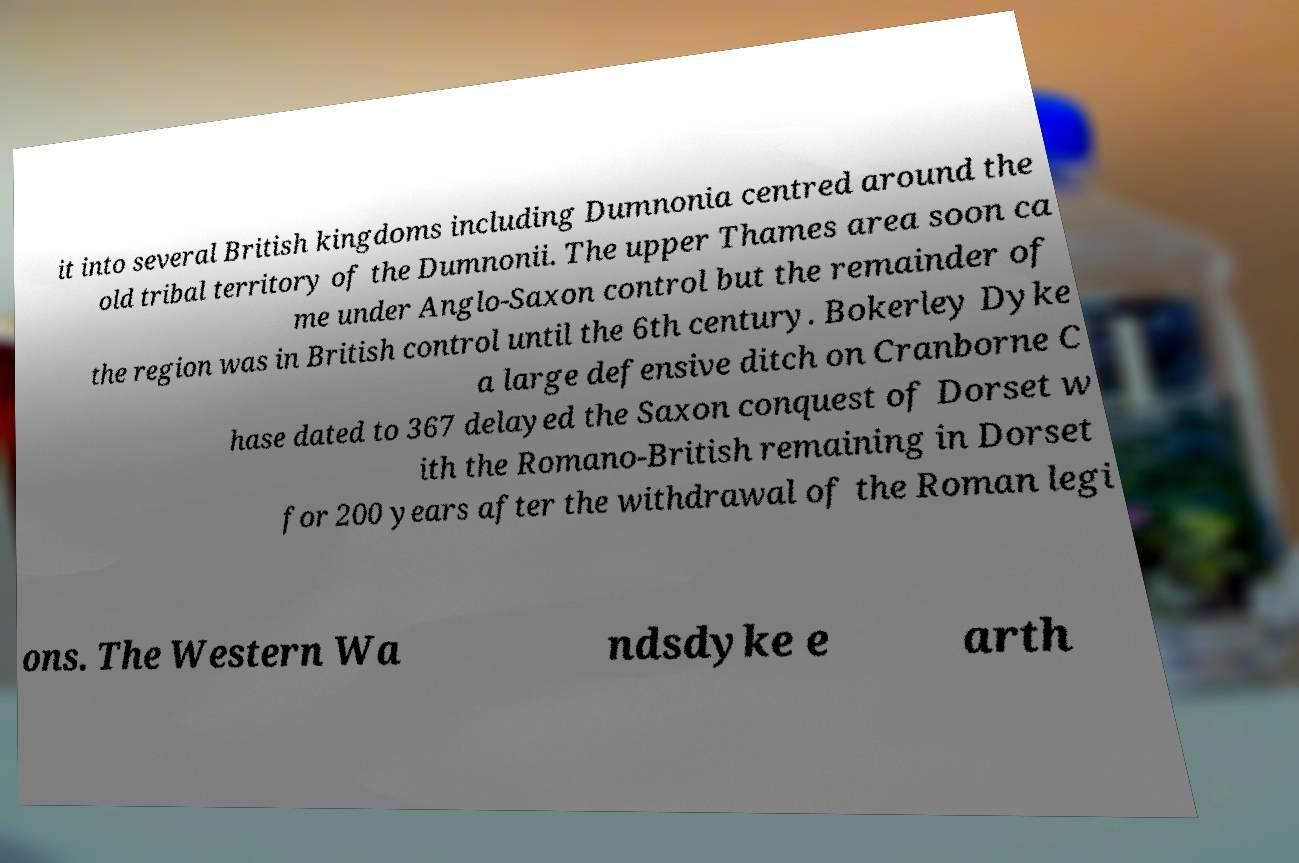Can you read and provide the text displayed in the image?This photo seems to have some interesting text. Can you extract and type it out for me? it into several British kingdoms including Dumnonia centred around the old tribal territory of the Dumnonii. The upper Thames area soon ca me under Anglo-Saxon control but the remainder of the region was in British control until the 6th century. Bokerley Dyke a large defensive ditch on Cranborne C hase dated to 367 delayed the Saxon conquest of Dorset w ith the Romano-British remaining in Dorset for 200 years after the withdrawal of the Roman legi ons. The Western Wa ndsdyke e arth 